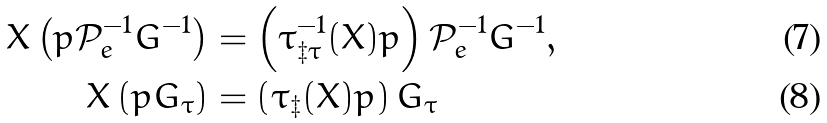<formula> <loc_0><loc_0><loc_500><loc_500>X \left ( p \mathcal { P } _ { e } ^ { - 1 } G ^ { - 1 } \right ) & = \left ( \tau _ { \ddagger \tau } ^ { - 1 } ( X ) p \right ) \mathcal { P } _ { e } ^ { - 1 } G ^ { - 1 } , \\ X \left ( p G _ { \tau } \right ) & = \left ( \tau _ { \ddagger } ( X ) p \right ) G _ { \tau }</formula> 